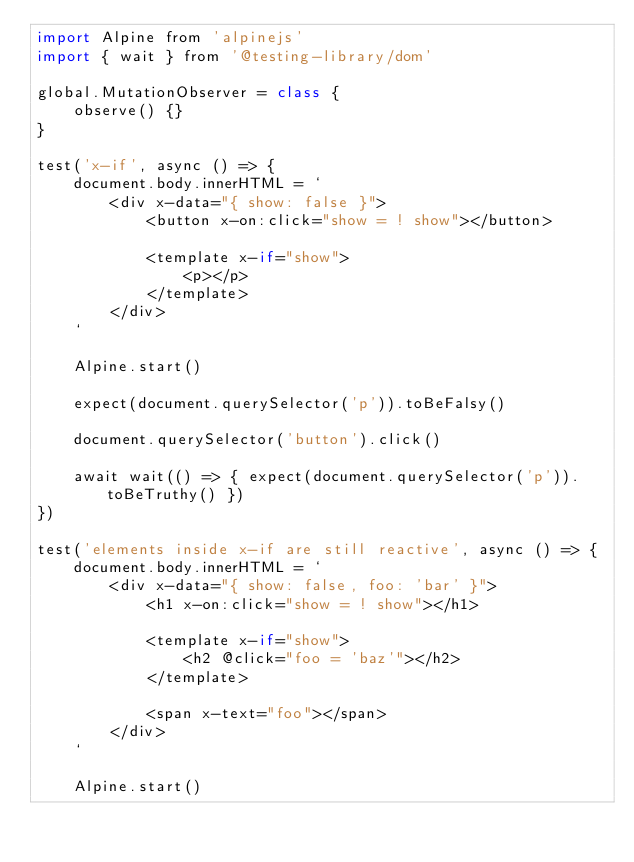Convert code to text. <code><loc_0><loc_0><loc_500><loc_500><_JavaScript_>import Alpine from 'alpinejs'
import { wait } from '@testing-library/dom'

global.MutationObserver = class {
    observe() {}
}

test('x-if', async () => {
    document.body.innerHTML = `
        <div x-data="{ show: false }">
            <button x-on:click="show = ! show"></button>

            <template x-if="show">
                <p></p>
            </template>
        </div>
    `

    Alpine.start()

    expect(document.querySelector('p')).toBeFalsy()

    document.querySelector('button').click()

    await wait(() => { expect(document.querySelector('p')).toBeTruthy() })
})

test('elements inside x-if are still reactive', async () => {
    document.body.innerHTML = `
        <div x-data="{ show: false, foo: 'bar' }">
            <h1 x-on:click="show = ! show"></h1>

            <template x-if="show">
                <h2 @click="foo = 'baz'"></h2>
            </template>

            <span x-text="foo"></span>
        </div>
    `

    Alpine.start()
</code> 